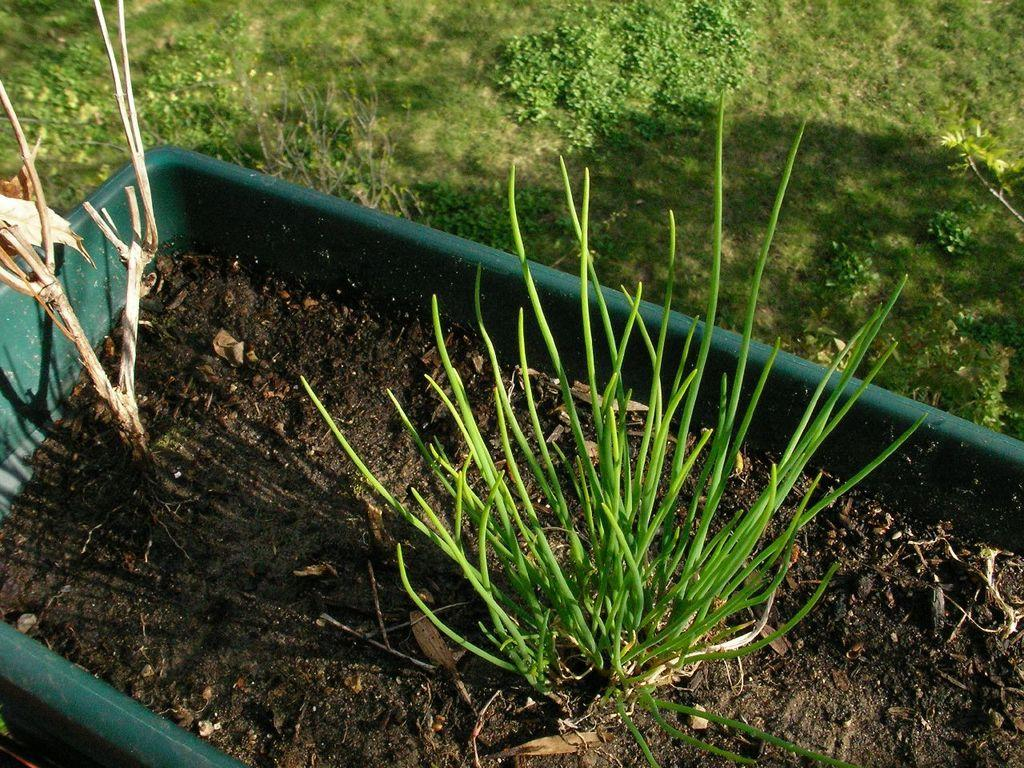What type of container is the plant in? The plant is in a green tub. What can be seen behind the green tub? There is grass behind the green tub. What type of pencil is being used to draw the plant in the image? There is no pencil present in the image, as it is a photograph of a real plant in a green tub. 